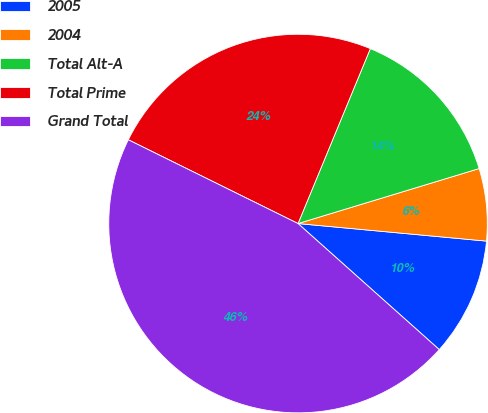Convert chart. <chart><loc_0><loc_0><loc_500><loc_500><pie_chart><fcel>2005<fcel>2004<fcel>Total Alt-A<fcel>Total Prime<fcel>Grand Total<nl><fcel>10.12%<fcel>6.17%<fcel>14.07%<fcel>23.94%<fcel>45.7%<nl></chart> 